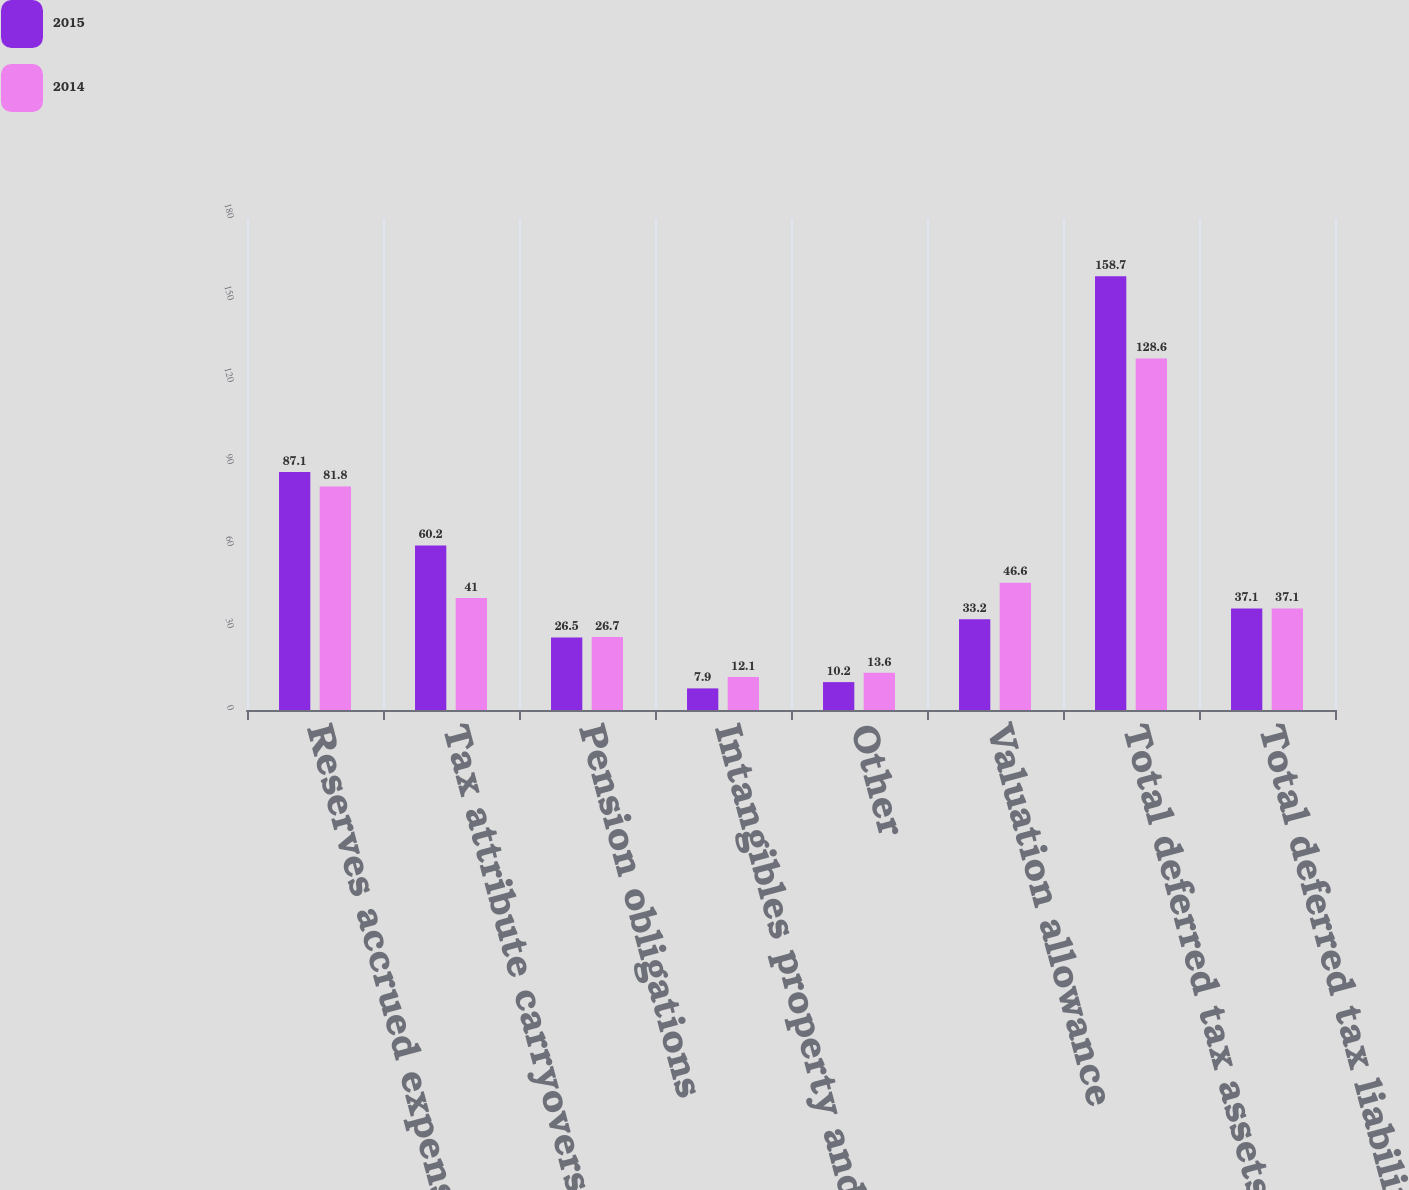Convert chart. <chart><loc_0><loc_0><loc_500><loc_500><stacked_bar_chart><ecel><fcel>Reserves accrued expenses and<fcel>Tax attribute carryovers<fcel>Pension obligations<fcel>Intangibles property and<fcel>Other<fcel>Valuation allowance<fcel>Total deferred tax assets<fcel>Total deferred tax liabilities<nl><fcel>2015<fcel>87.1<fcel>60.2<fcel>26.5<fcel>7.9<fcel>10.2<fcel>33.2<fcel>158.7<fcel>37.1<nl><fcel>2014<fcel>81.8<fcel>41<fcel>26.7<fcel>12.1<fcel>13.6<fcel>46.6<fcel>128.6<fcel>37.1<nl></chart> 